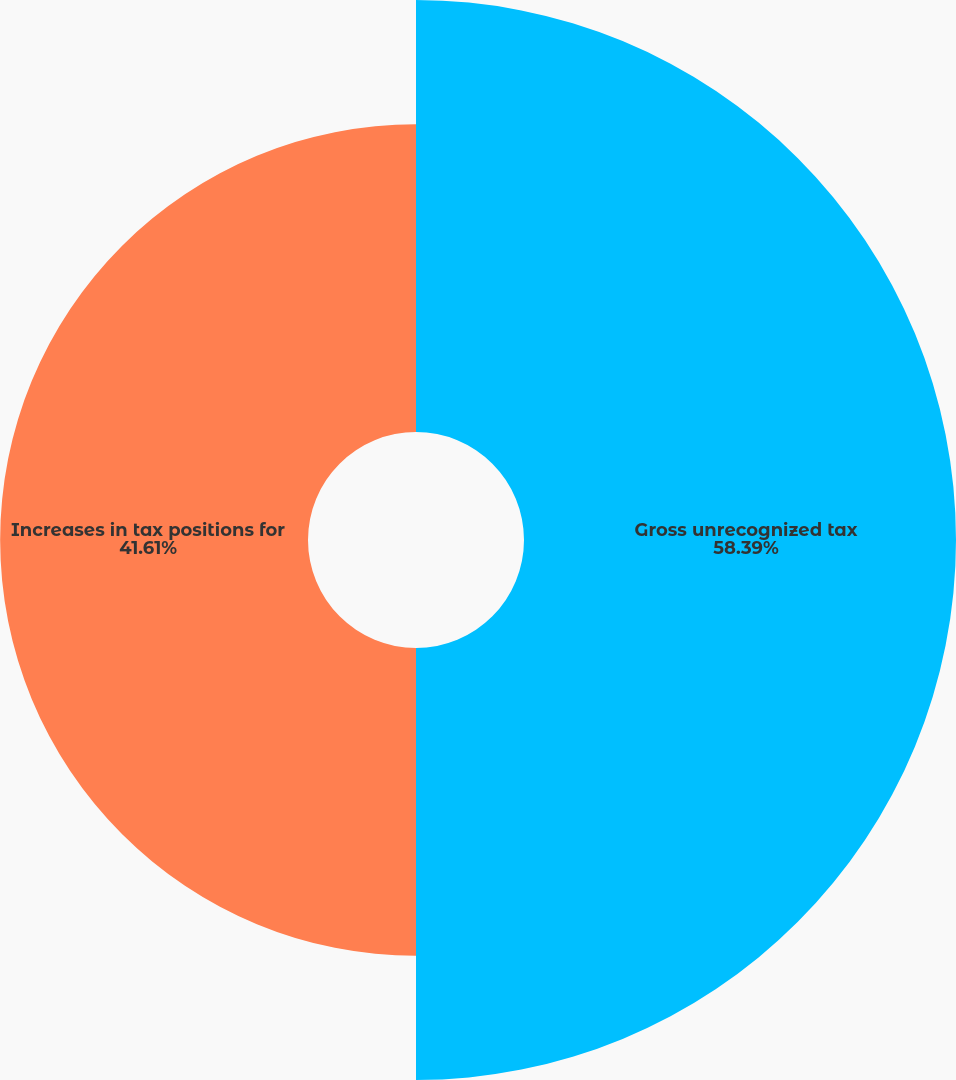Convert chart. <chart><loc_0><loc_0><loc_500><loc_500><pie_chart><fcel>Gross unrecognized tax<fcel>Increases in tax positions for<nl><fcel>58.39%<fcel>41.61%<nl></chart> 